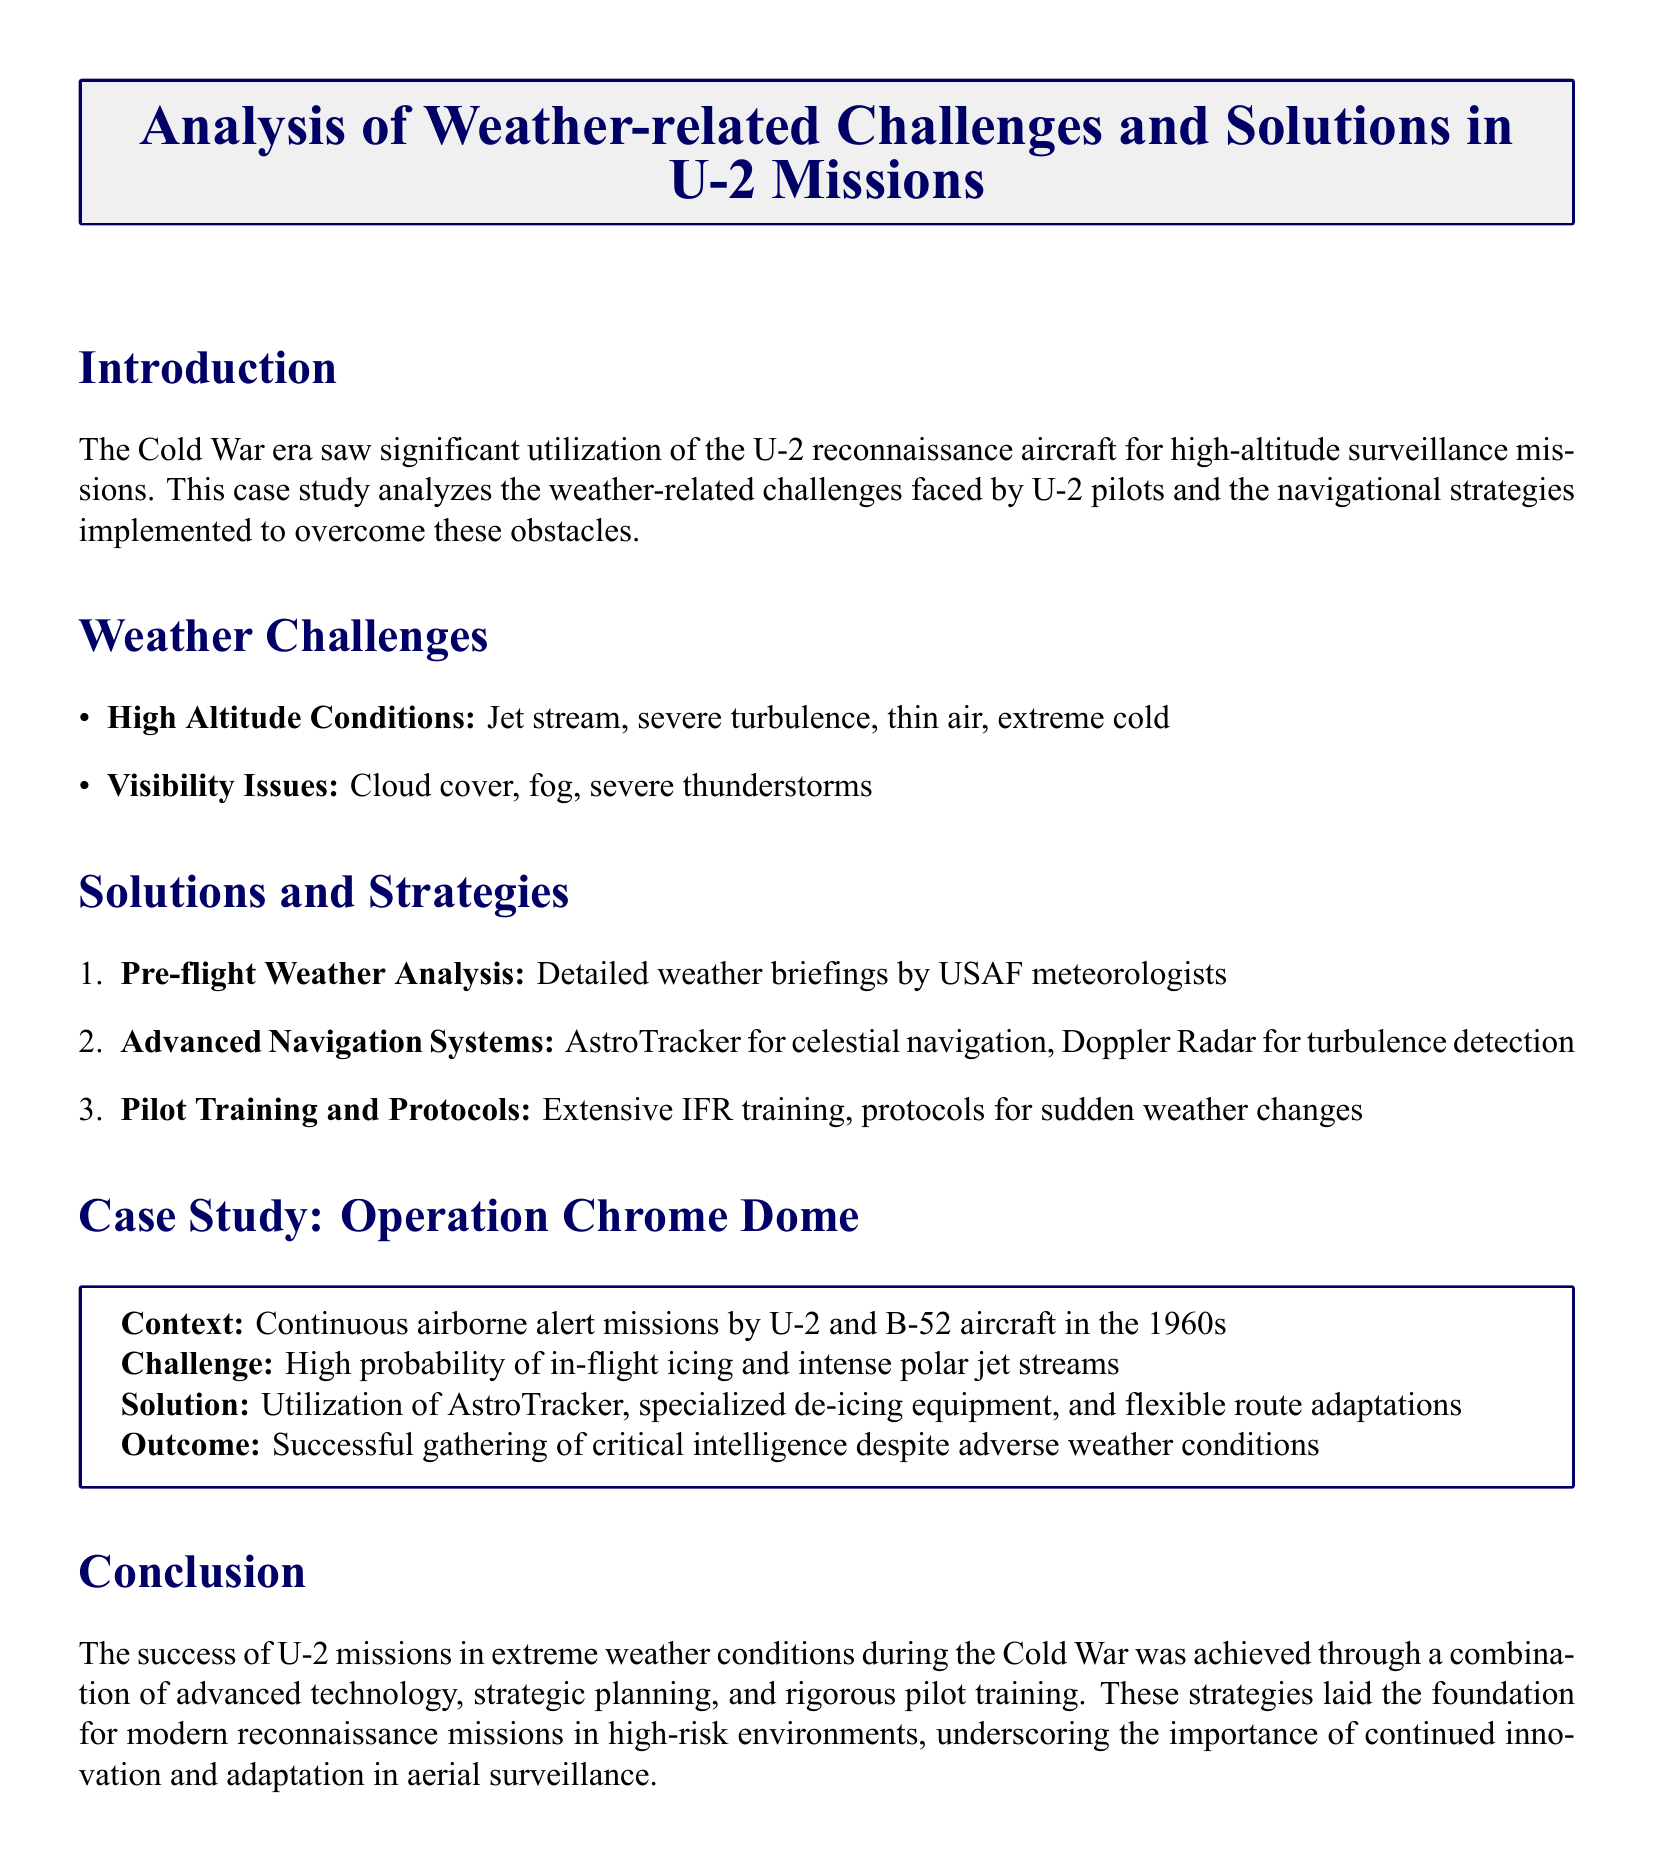What are the primary weather challenges faced by U-2 pilots? The document lists high altitude conditions and visibility issues as the primary weather challenges faced by U-2 pilots.
Answer: High altitude conditions, visibility issues What advanced navigation system is mentioned for celestial navigation? The document specifies the AstroTracker as the advanced navigation system used for celestial navigation.
Answer: AstroTracker What is the focus of the case study presented in the document? The case study focuses on analyzing weather-related challenges and navigational strategies in U-2 missions.
Answer: Weather-related challenges and navigational strategies in U-2 missions In what year did the continuous airborne alert missions of Operation Chrome Dome occur? Although the document does not provide a specific year, it notes that Operation Chrome Dome took place in the 1960s.
Answer: 1960s What specialized equipment was used to combat in-flight icing? The document mentions the use of specialized de-icing equipment to combat in-flight icing.
Answer: Specialized de-icing equipment What pre-flight analysis is critical according to the document? The document emphasizes detailed weather briefings by USAF meteorologists as a critical pre-flight analysis.
Answer: Detailed weather briefings by USAF meteorologists What was the outcome of Operation Chrome Dome despite adverse weather? The document states that the outcome was the successful gathering of critical intelligence despite adverse weather conditions.
Answer: Successful gathering of critical intelligence What type of training is mentioned as extensive for U-2 pilots? Extensive IFR training is mentioned as critical for U-2 pilots in the document.
Answer: Extensive IFR training 